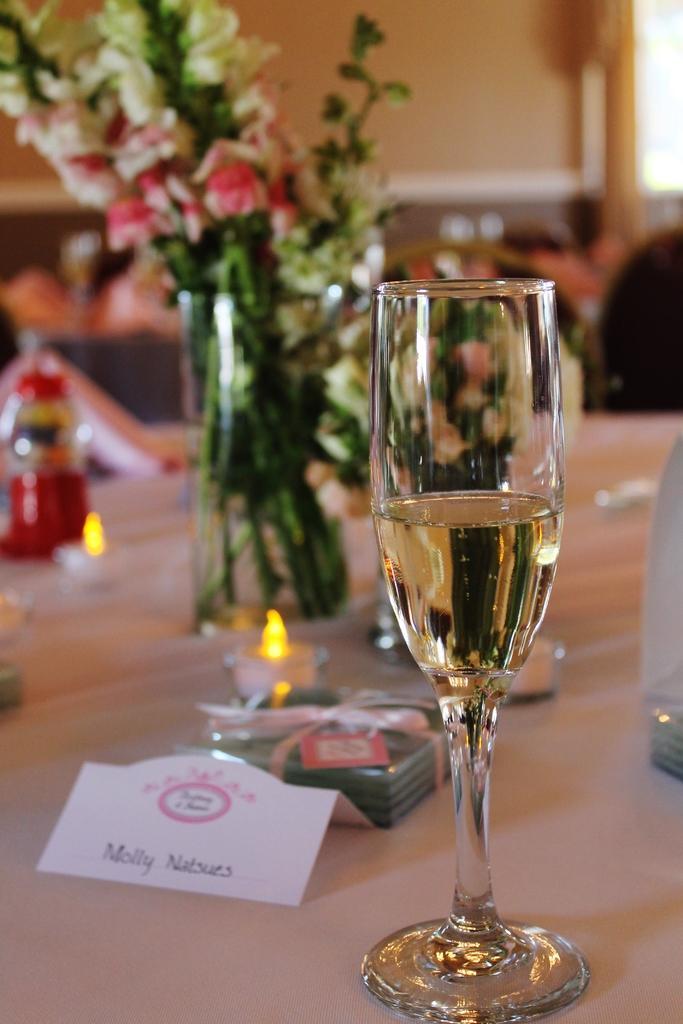Describe this image in one or two sentences. In this picture we can see a glass with drink in it and a name card, flower vase, bottle, some objects and these all are on a platform and in the background we can see a wall, people and it is blurry. 